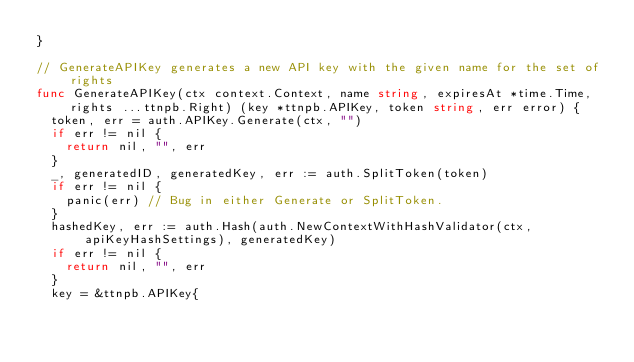<code> <loc_0><loc_0><loc_500><loc_500><_Go_>}

// GenerateAPIKey generates a new API key with the given name for the set of rights
func GenerateAPIKey(ctx context.Context, name string, expiresAt *time.Time, rights ...ttnpb.Right) (key *ttnpb.APIKey, token string, err error) {
	token, err = auth.APIKey.Generate(ctx, "")
	if err != nil {
		return nil, "", err
	}
	_, generatedID, generatedKey, err := auth.SplitToken(token)
	if err != nil {
		panic(err) // Bug in either Generate or SplitToken.
	}
	hashedKey, err := auth.Hash(auth.NewContextWithHashValidator(ctx, apiKeyHashSettings), generatedKey)
	if err != nil {
		return nil, "", err
	}
	key = &ttnpb.APIKey{</code> 